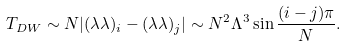Convert formula to latex. <formula><loc_0><loc_0><loc_500><loc_500>T _ { D W } \sim N | ( \lambda \lambda ) _ { i } - ( \lambda \lambda ) _ { j } | \sim N ^ { 2 } \Lambda ^ { 3 } \sin \frac { ( i - j ) \pi } { N } .</formula> 